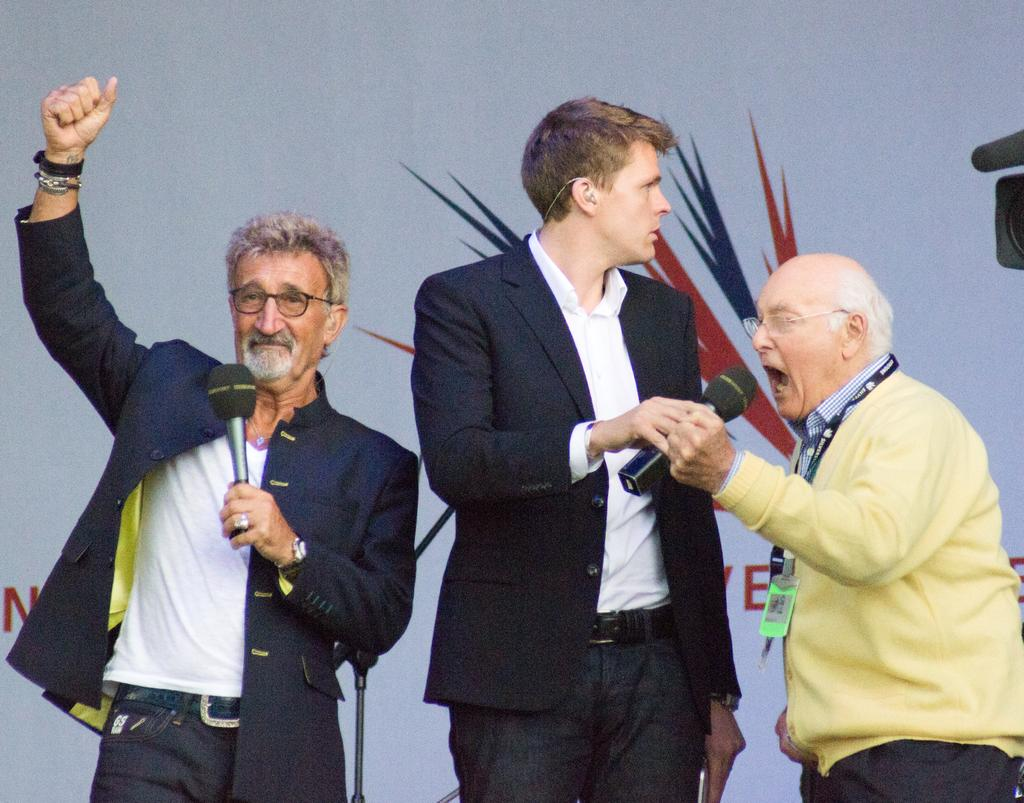How many people are present in the image? There are three men standing in the image. What is one of the men doing with a microphone? One man is speaking with the help of a microphone in his hand. What is the other man with a microphone doing? Another man is holding a microphone in his hand. What type of crime is being committed by the man with the microphone in the image? There is no indication of a crime being committed in the image; the men are simply holding microphones. 